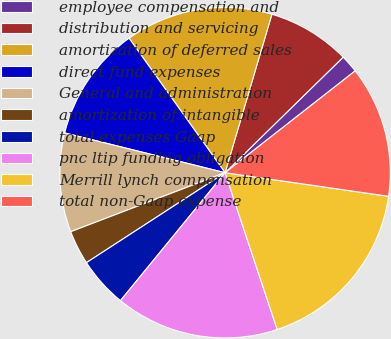<chart> <loc_0><loc_0><loc_500><loc_500><pie_chart><fcel>employee compensation and<fcel>distribution and servicing<fcel>amortization of deferred sales<fcel>direct fund expenses<fcel>General and administration<fcel>amortization of intangible<fcel>total expenses Gaap<fcel>pnc ltip funding obligation<fcel>Merrill lynch compensation<fcel>total non-Gaap expense<nl><fcel>1.76%<fcel>8.1%<fcel>14.44%<fcel>11.27%<fcel>9.68%<fcel>3.35%<fcel>4.93%<fcel>16.02%<fcel>17.61%<fcel>12.85%<nl></chart> 